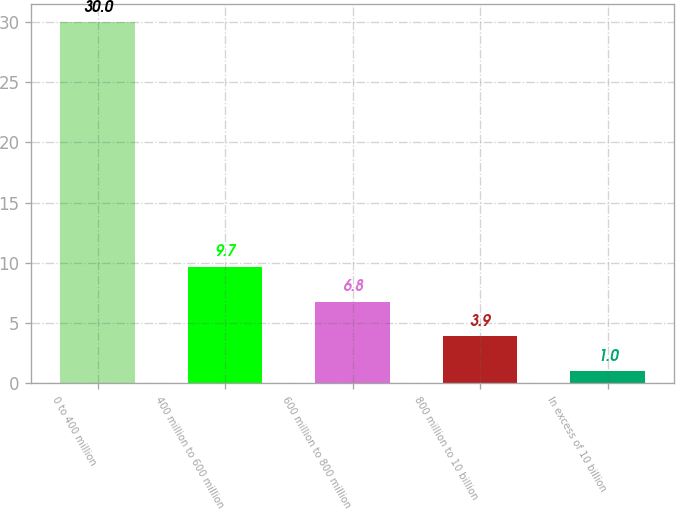Convert chart to OTSL. <chart><loc_0><loc_0><loc_500><loc_500><bar_chart><fcel>0 to 400 million<fcel>400 million to 600 million<fcel>600 million to 800 million<fcel>800 million to 10 billion<fcel>In excess of 10 billion<nl><fcel>30<fcel>9.7<fcel>6.8<fcel>3.9<fcel>1<nl></chart> 